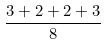<formula> <loc_0><loc_0><loc_500><loc_500>\frac { 3 + 2 + 2 + 3 } { 8 }</formula> 